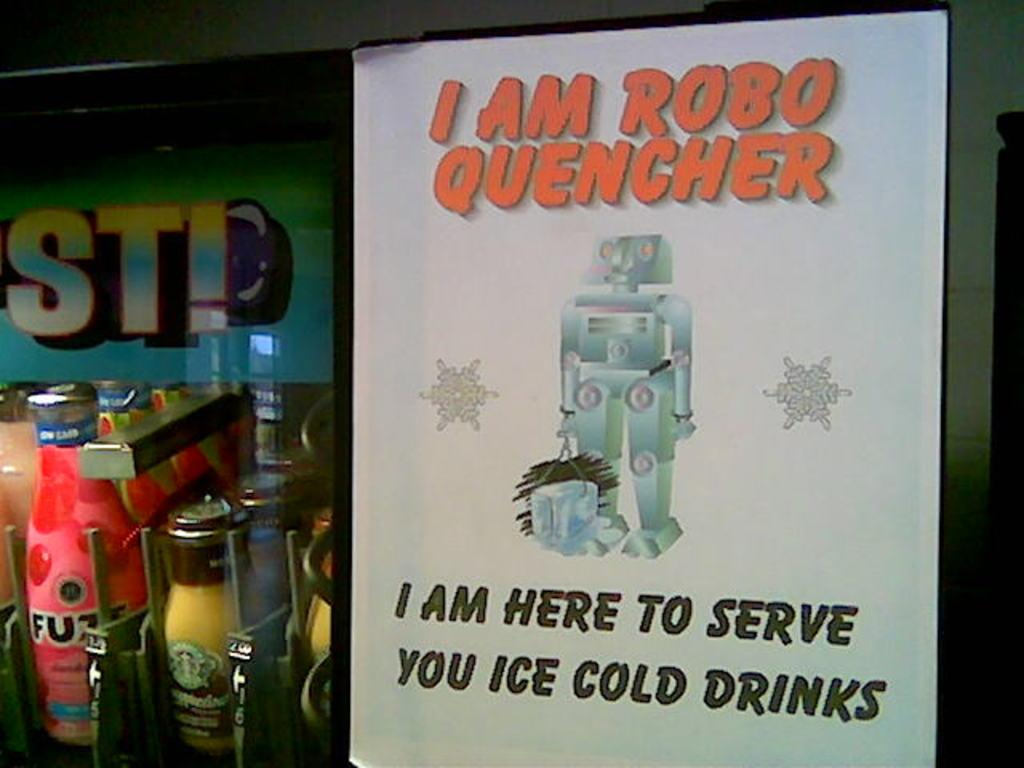What objects are located on the left side of the image? There are bottles on the left side of the image. What can be seen on the right side of the image? There is a paper on the right side of the image. Can you see any connection between the bottles and the paper in the image? There is no visible connection between the bottles and the paper in the image. Are there any cats or fairies present in the image? There is no mention of cats or fairies in the provided facts, and therefore they are not present in the image. 